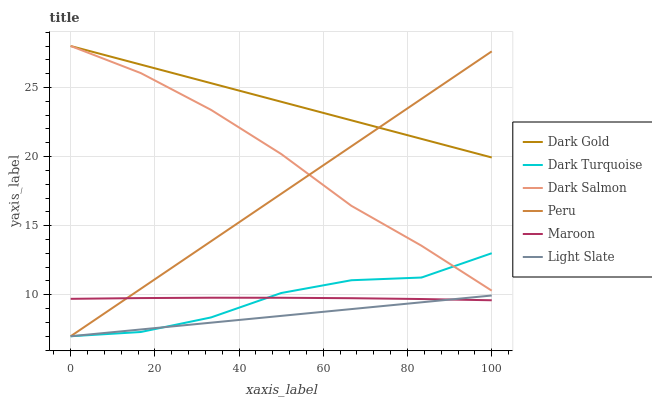Does Dark Turquoise have the minimum area under the curve?
Answer yes or no. No. Does Dark Turquoise have the maximum area under the curve?
Answer yes or no. No. Is Dark Turquoise the smoothest?
Answer yes or no. No. Is Light Slate the roughest?
Answer yes or no. No. Does Dark Salmon have the lowest value?
Answer yes or no. No. Does Light Slate have the highest value?
Answer yes or no. No. Is Maroon less than Dark Gold?
Answer yes or no. Yes. Is Dark Salmon greater than Light Slate?
Answer yes or no. Yes. Does Maroon intersect Dark Gold?
Answer yes or no. No. 